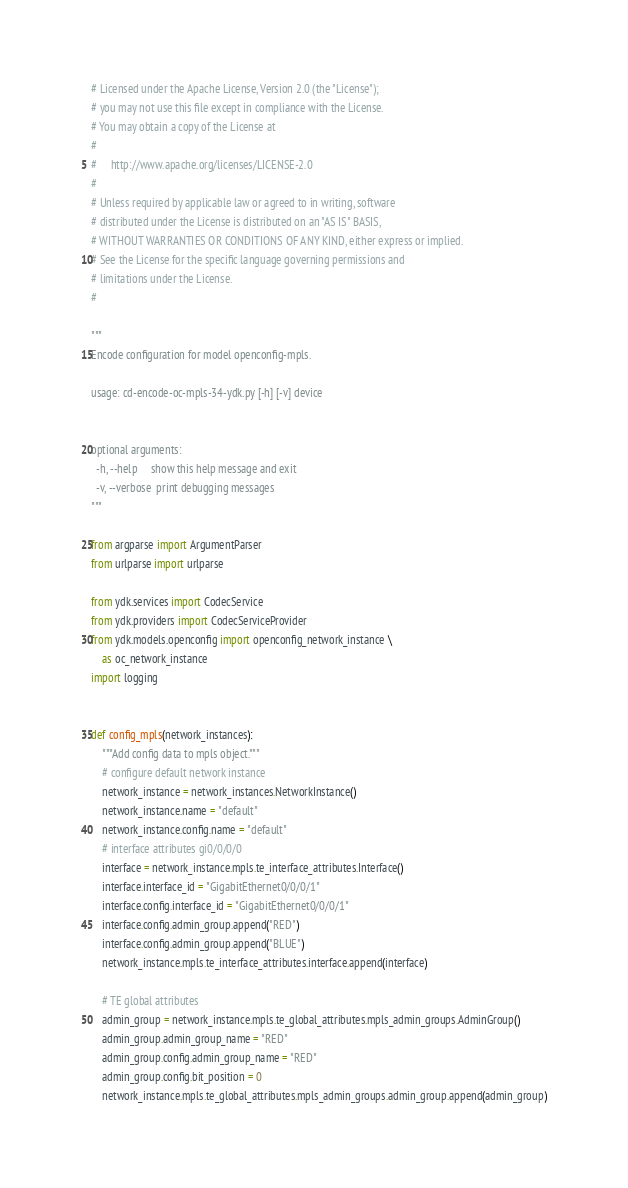Convert code to text. <code><loc_0><loc_0><loc_500><loc_500><_Python_># Licensed under the Apache License, Version 2.0 (the "License");
# you may not use this file except in compliance with the License.
# You may obtain a copy of the License at
#
#     http://www.apache.org/licenses/LICENSE-2.0
#
# Unless required by applicable law or agreed to in writing, software
# distributed under the License is distributed on an "AS IS" BASIS,
# WITHOUT WARRANTIES OR CONDITIONS OF ANY KIND, either express or implied.
# See the License for the specific language governing permissions and
# limitations under the License.
#

"""
Encode configuration for model openconfig-mpls.

usage: cd-encode-oc-mpls-34-ydk.py [-h] [-v] device


optional arguments:
  -h, --help     show this help message and exit
  -v, --verbose  print debugging messages
"""

from argparse import ArgumentParser
from urlparse import urlparse

from ydk.services import CodecService
from ydk.providers import CodecServiceProvider
from ydk.models.openconfig import openconfig_network_instance \
    as oc_network_instance
import logging


def config_mpls(network_instances):
    """Add config data to mpls object."""
    # configure default network instance
    network_instance = network_instances.NetworkInstance()
    network_instance.name = "default"
    network_instance.config.name = "default"
    # interface attributes gi0/0/0/0
    interface = network_instance.mpls.te_interface_attributes.Interface()
    interface.interface_id = "GigabitEthernet0/0/0/1"
    interface.config.interface_id = "GigabitEthernet0/0/0/1"
    interface.config.admin_group.append("RED")
    interface.config.admin_group.append("BLUE")
    network_instance.mpls.te_interface_attributes.interface.append(interface)

    # TE global attributes
    admin_group = network_instance.mpls.te_global_attributes.mpls_admin_groups.AdminGroup()
    admin_group.admin_group_name = "RED"
    admin_group.config.admin_group_name = "RED"
    admin_group.config.bit_position = 0
    network_instance.mpls.te_global_attributes.mpls_admin_groups.admin_group.append(admin_group)</code> 